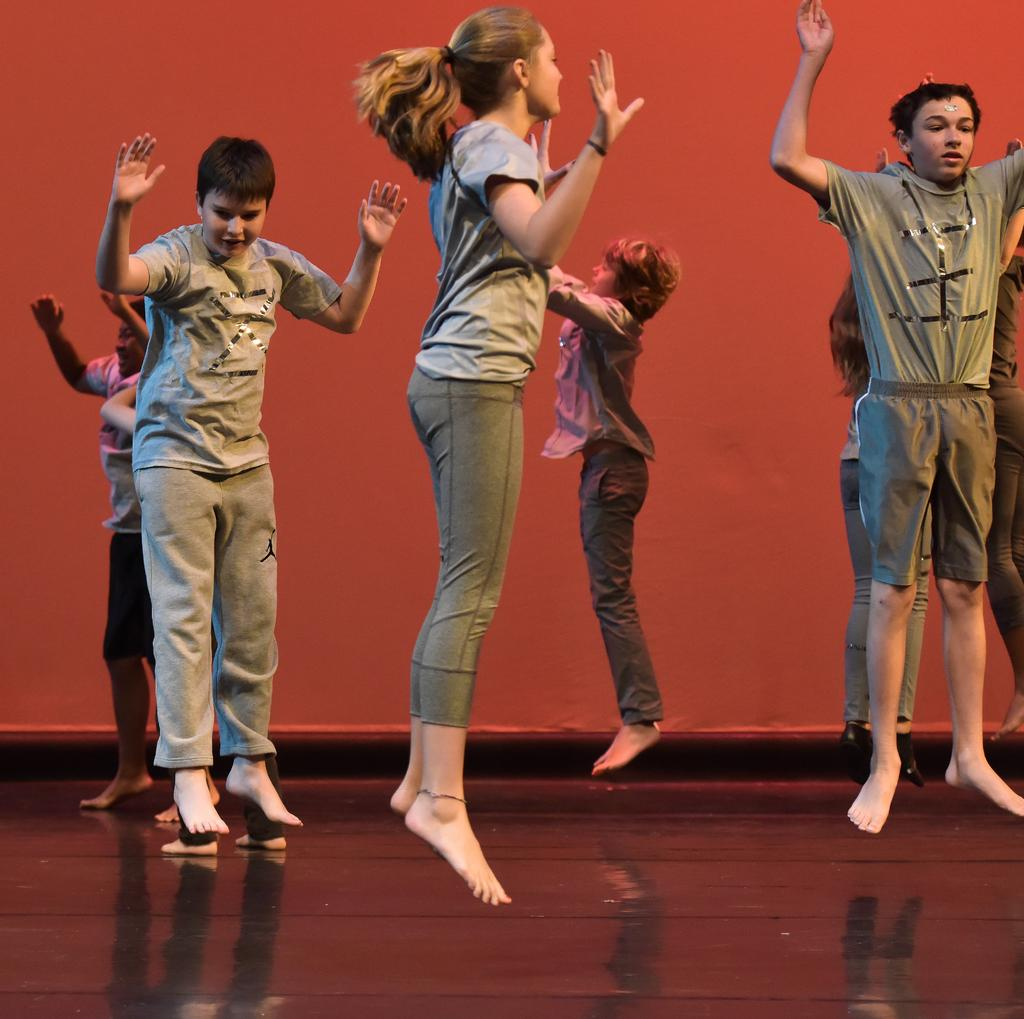Who or what is present in the image? There are people in the image. What are the people doing in the image? The people are jumping. What is the color of the background in the image? The background color is red. What type of scissors can be seen in the image? There are no scissors present in the image. What is the weight of the people in the image? The weight of the people cannot be determined from the image alone. 